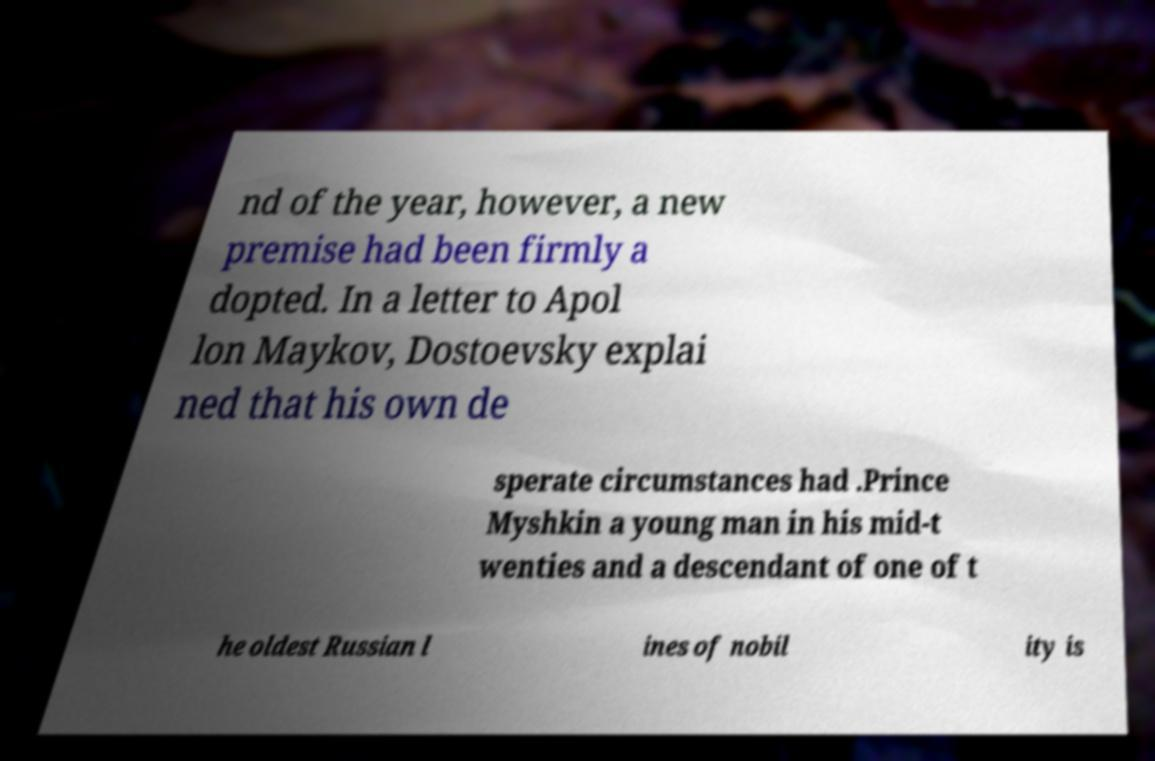I need the written content from this picture converted into text. Can you do that? nd of the year, however, a new premise had been firmly a dopted. In a letter to Apol lon Maykov, Dostoevsky explai ned that his own de sperate circumstances had .Prince Myshkin a young man in his mid-t wenties and a descendant of one of t he oldest Russian l ines of nobil ity is 